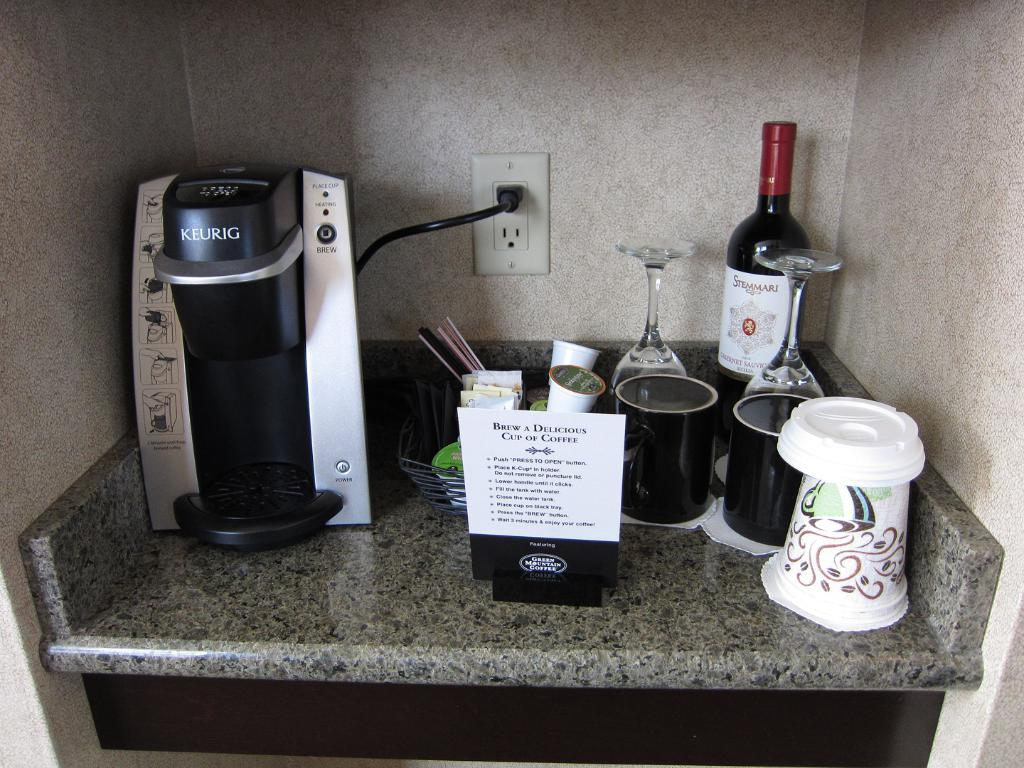What appliance can be seen in the image? There is a coffee machine in the image. How many black cups are visible in the image? There are two black cups in the image. What type of glasses are present in the image? There are wine glasses in the image. What is the alcoholic beverage container in the image? There is a wine bottle in the image. What is the container with multiple objects in the image? There is a basket with objects in the image. What is the paper placed on in the image? The paper is placed on the marble stone in the image. Where is the socket located in the image? There is a socket attached to the wall in the image. What direction is the vegetable facing in the image? There is no vegetable present in the image. 